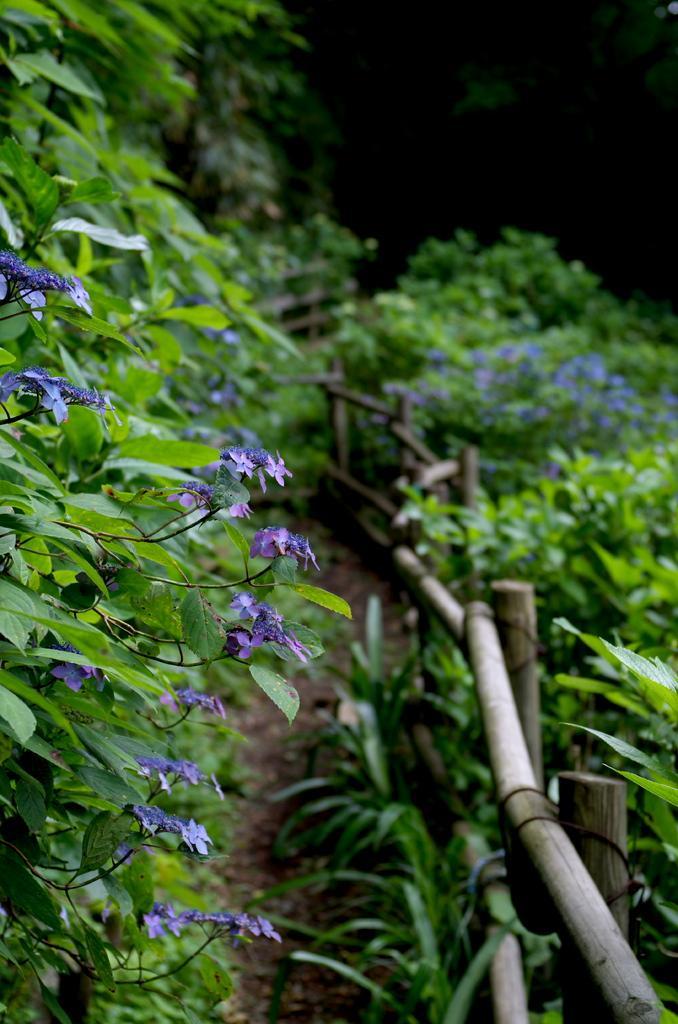Could you give a brief overview of what you see in this image? In this image we can see plants with flowers. Also there is a wooden fencing. In the background it is blur. 